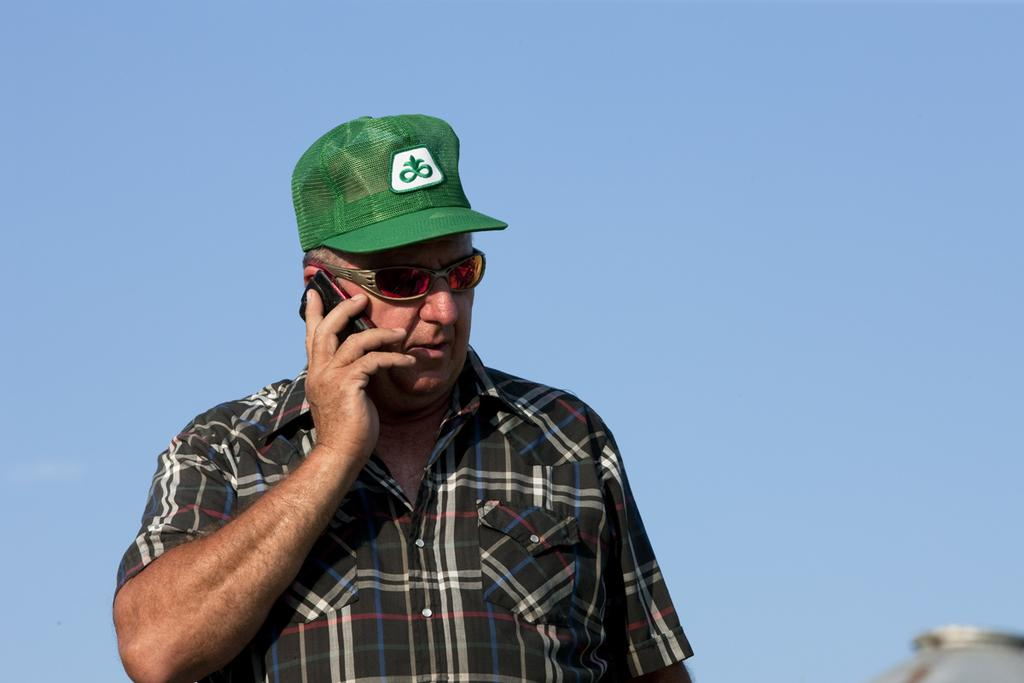Who is the main subject in the image? There is a man in the image. What is the man holding in the image? The man is holding a mobile phone. What can be seen on the man's head in the image? The man is wearing a green cap. What is visible in the background of the image? The sky is visible in the background of the image. In which direction is the man rolling in the image? The man is not rolling in the image; he is standing still while holding a mobile phone. 